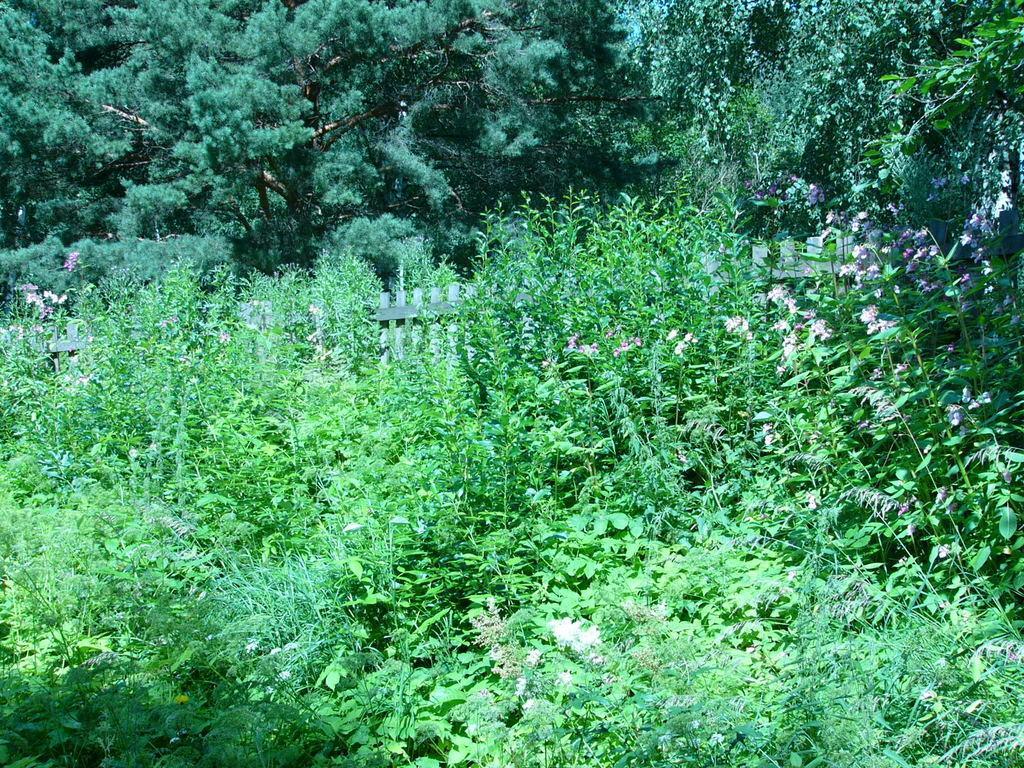Could you give a brief overview of what you see in this image? In this image we can see wooden fencing, trees and plants. 